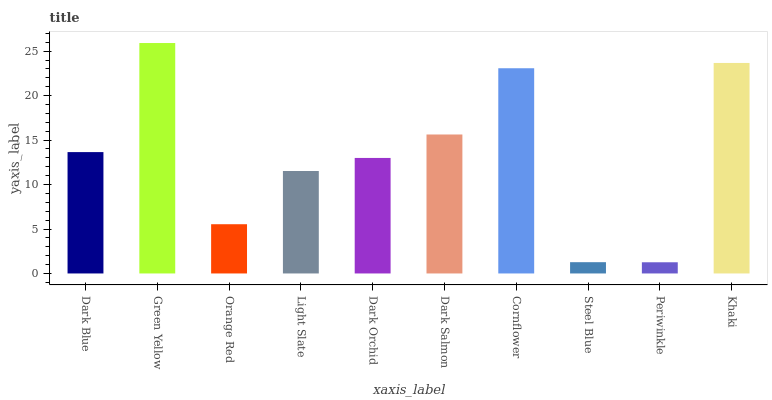Is Orange Red the minimum?
Answer yes or no. No. Is Orange Red the maximum?
Answer yes or no. No. Is Green Yellow greater than Orange Red?
Answer yes or no. Yes. Is Orange Red less than Green Yellow?
Answer yes or no. Yes. Is Orange Red greater than Green Yellow?
Answer yes or no. No. Is Green Yellow less than Orange Red?
Answer yes or no. No. Is Dark Blue the high median?
Answer yes or no. Yes. Is Dark Orchid the low median?
Answer yes or no. Yes. Is Cornflower the high median?
Answer yes or no. No. Is Orange Red the low median?
Answer yes or no. No. 